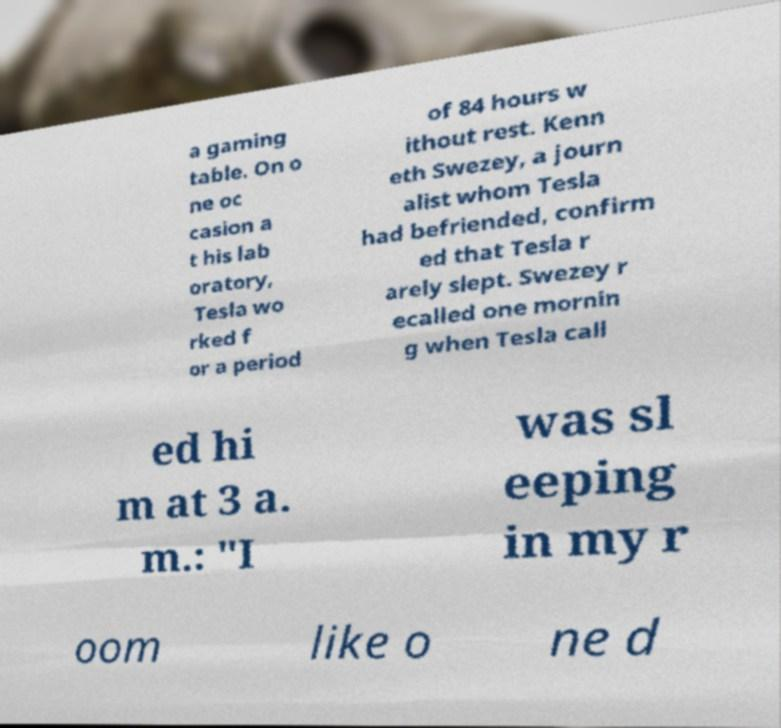What messages or text are displayed in this image? I need them in a readable, typed format. a gaming table. On o ne oc casion a t his lab oratory, Tesla wo rked f or a period of 84 hours w ithout rest. Kenn eth Swezey, a journ alist whom Tesla had befriended, confirm ed that Tesla r arely slept. Swezey r ecalled one mornin g when Tesla call ed hi m at 3 a. m.: "I was sl eeping in my r oom like o ne d 